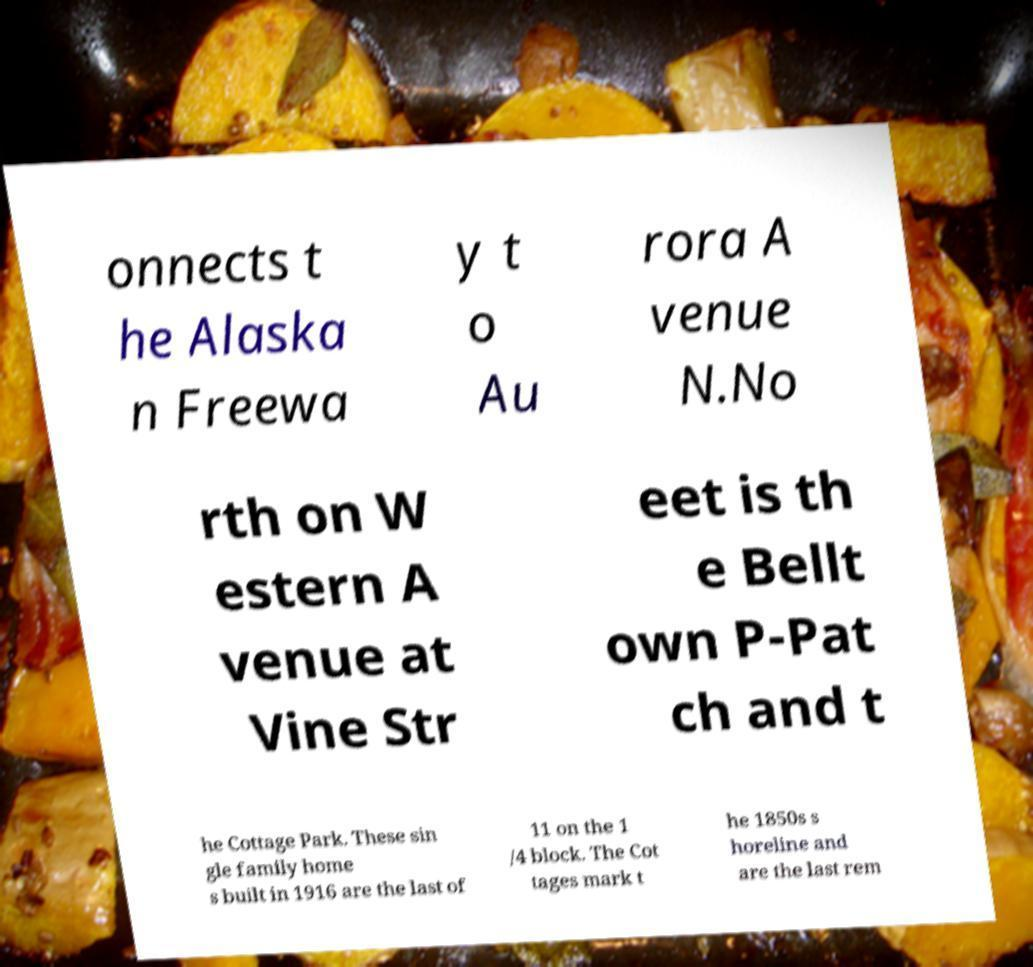Please read and relay the text visible in this image. What does it say? onnects t he Alaska n Freewa y t o Au rora A venue N.No rth on W estern A venue at Vine Str eet is th e Bellt own P-Pat ch and t he Cottage Park. These sin gle family home s built in 1916 are the last of 11 on the 1 /4 block. The Cot tages mark t he 1850s s horeline and are the last rem 